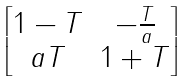<formula> <loc_0><loc_0><loc_500><loc_500>\begin{bmatrix} 1 - T & - \frac { T } { a } \\ a T & 1 + T \end{bmatrix}</formula> 